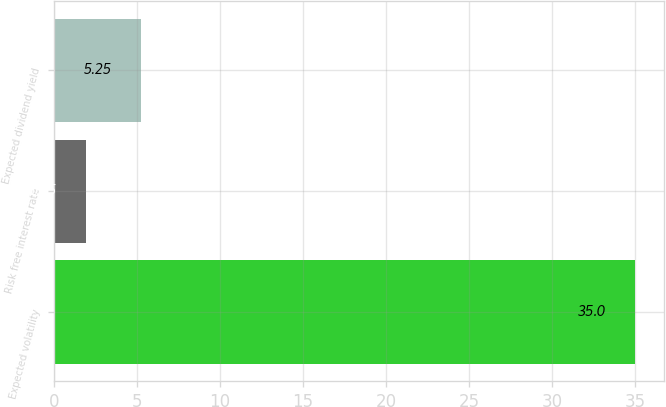Convert chart to OTSL. <chart><loc_0><loc_0><loc_500><loc_500><bar_chart><fcel>Expected volatility<fcel>Risk free interest rate<fcel>Expected dividend yield<nl><fcel>35<fcel>1.95<fcel>5.25<nl></chart> 